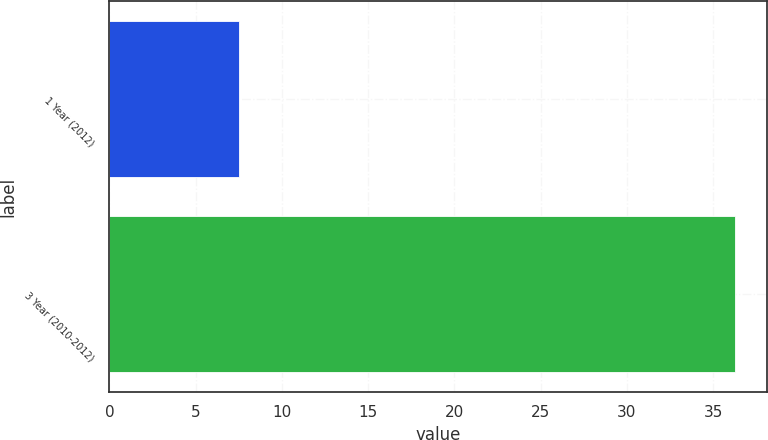Convert chart to OTSL. <chart><loc_0><loc_0><loc_500><loc_500><bar_chart><fcel>1 Year (2012)<fcel>3 Year (2010-2012)<nl><fcel>7.5<fcel>36.3<nl></chart> 